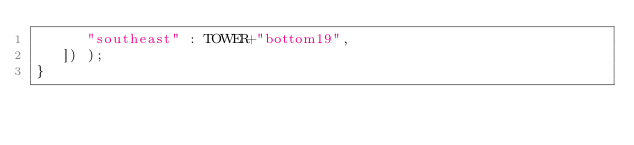Convert code to text. <code><loc_0><loc_0><loc_500><loc_500><_C_>      "southeast" : TOWER+"bottom19",
   ]) );
}</code> 